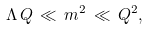Convert formula to latex. <formula><loc_0><loc_0><loc_500><loc_500>\Lambda \, Q \, \ll \, m ^ { 2 } \, \ll \, Q ^ { 2 } ,</formula> 